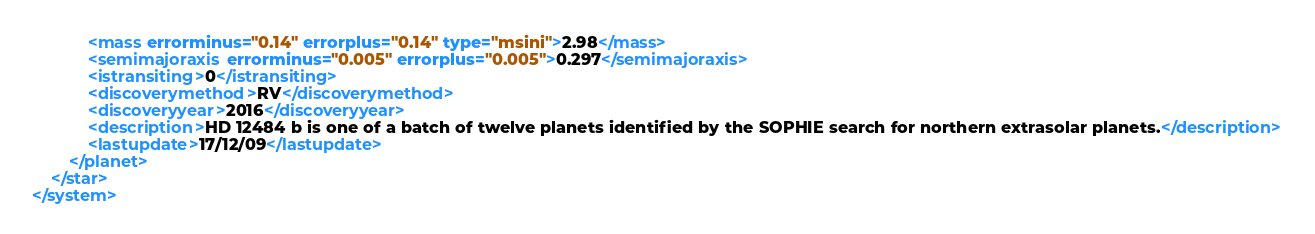Convert code to text. <code><loc_0><loc_0><loc_500><loc_500><_XML_>			<mass errorminus="0.14" errorplus="0.14" type="msini">2.98</mass>
			<semimajoraxis errorminus="0.005" errorplus="0.005">0.297</semimajoraxis>
			<istransiting>0</istransiting>
			<discoverymethod>RV</discoverymethod>
			<discoveryyear>2016</discoveryyear>
			<description>HD 12484 b is one of a batch of twelve planets identified by the SOPHIE search for northern extrasolar planets.</description>
			<lastupdate>17/12/09</lastupdate>
		</planet>
	</star>
</system>
</code> 